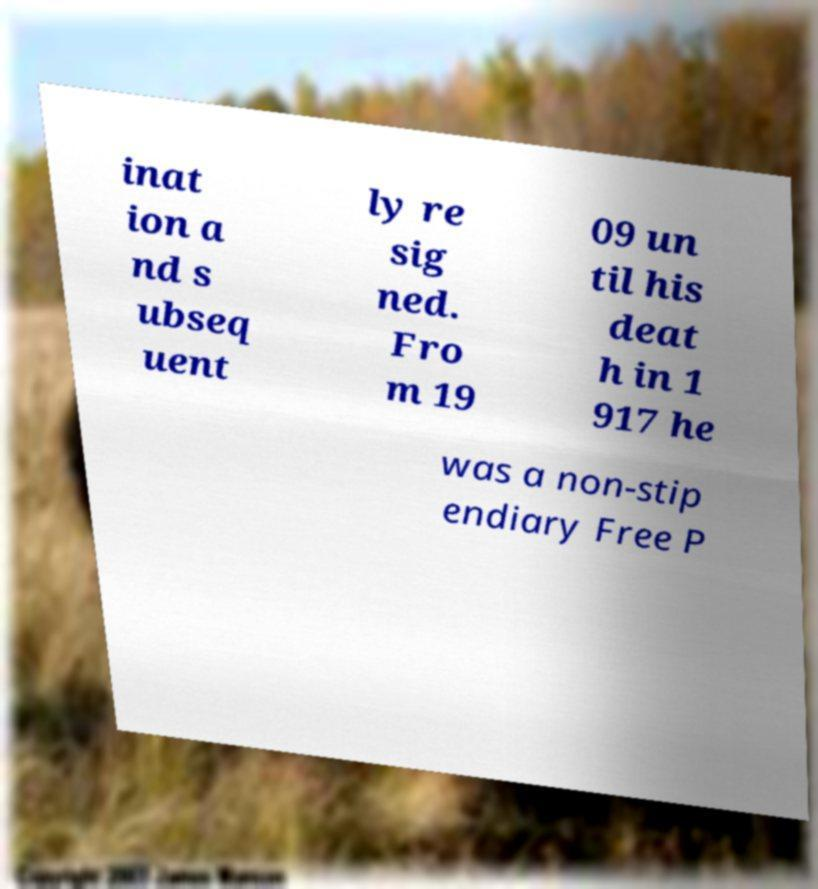Could you extract and type out the text from this image? inat ion a nd s ubseq uent ly re sig ned. Fro m 19 09 un til his deat h in 1 917 he was a non-stip endiary Free P 